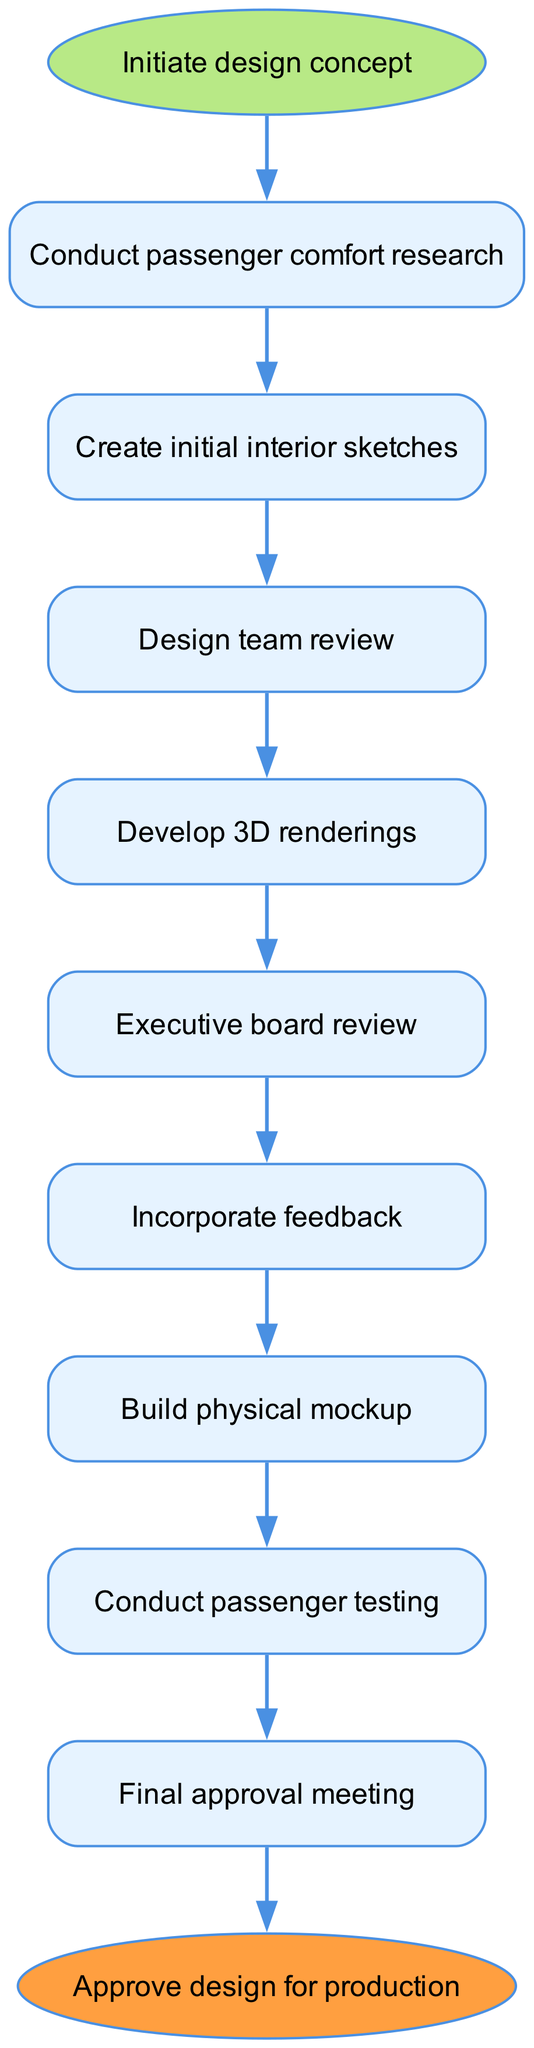What is the first step in the design approval workflow? The first step is labeled as "Initiate design concept," which is the starting point of the entire process. It is the node at the top of the flow chart.
Answer: Initiate design concept How many total nodes are in the diagram? The diagram consists of 11 nodes, counting the "start" and "end" nodes as well. These nodes represent the various steps in the workflow.
Answer: 11 What follows the "Design team review" step? After the "Design team review" step, the workflow moves to the "Develop 3D renderings" step, as indicated by the directed edge connecting these two nodes.
Answer: Develop 3D renderings What is the purpose of the "Incorporate feedback" step? The "Incorporate feedback" step is where feedback from the "Executive board review" is integrated into the design. This step is crucial for refining the interior concepts based on the board's input.
Answer: To integrate feedback Which step comes before "Final approval meeting"? The step that comes immediately before "Final approval meeting" is "Conduct passenger testing." This indicates that testing occurs prior to the final review process, ensuring that the design meets passenger needs.
Answer: Conduct passenger testing If the workflow reaches "Final approval meeting," what must be achieved to proceed to the end node? To proceed to the end node from the "Final approval meeting," the design must receive approval during this meeting. This indicates a conclusive agreement on the design's readiness for production.
Answer: Approval How many steps are involved from "Initial interior sketches" to "Conduct passenger testing"? There are three steps involved: "Create initial interior sketches," "Build physical mockup," and "Conduct passenger testing." They represent the workflow from preliminary design to testing.
Answer: 3 What color represents the starting point in the diagram? The starting point "Initiate design concept" is represented by a green color (B8E986), which is visually distinguished from other nodes in the workflow.
Answer: Green 